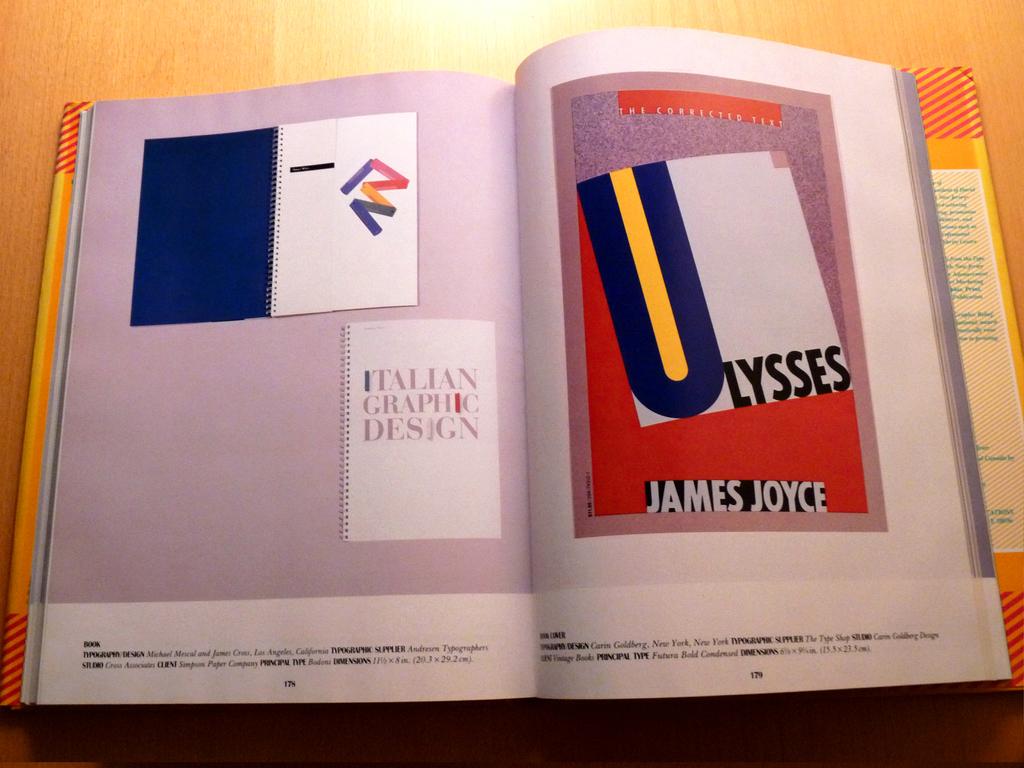Whose name is written on the page to the right?
Your answer should be very brief. James joyce. 